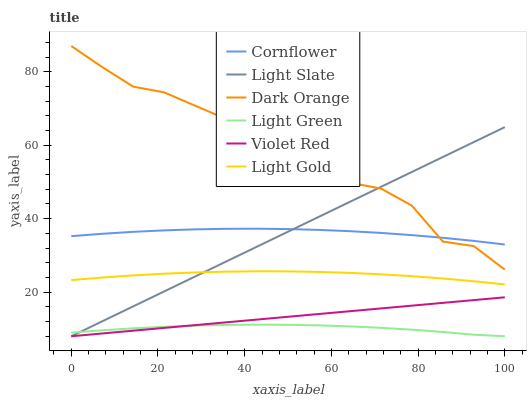Does Light Green have the minimum area under the curve?
Answer yes or no. Yes. Does Dark Orange have the maximum area under the curve?
Answer yes or no. Yes. Does Violet Red have the minimum area under the curve?
Answer yes or no. No. Does Violet Red have the maximum area under the curve?
Answer yes or no. No. Is Violet Red the smoothest?
Answer yes or no. Yes. Is Dark Orange the roughest?
Answer yes or no. Yes. Is Dark Orange the smoothest?
Answer yes or no. No. Is Violet Red the roughest?
Answer yes or no. No. Does Dark Orange have the lowest value?
Answer yes or no. No. Does Dark Orange have the highest value?
Answer yes or no. Yes. Does Violet Red have the highest value?
Answer yes or no. No. Is Light Gold less than Cornflower?
Answer yes or no. Yes. Is Cornflower greater than Light Green?
Answer yes or no. Yes. Does Dark Orange intersect Cornflower?
Answer yes or no. Yes. Is Dark Orange less than Cornflower?
Answer yes or no. No. Is Dark Orange greater than Cornflower?
Answer yes or no. No. Does Light Gold intersect Cornflower?
Answer yes or no. No. 